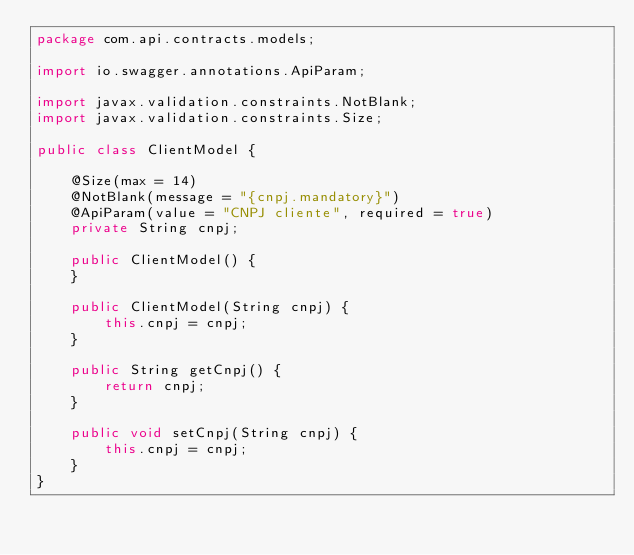Convert code to text. <code><loc_0><loc_0><loc_500><loc_500><_Java_>package com.api.contracts.models;

import io.swagger.annotations.ApiParam;

import javax.validation.constraints.NotBlank;
import javax.validation.constraints.Size;

public class ClientModel {

    @Size(max = 14)
    @NotBlank(message = "{cnpj.mandatory}")
    @ApiParam(value = "CNPJ cliente", required = true)
    private String cnpj;

    public ClientModel() {
    }

    public ClientModel(String cnpj) {
        this.cnpj = cnpj;
    }

    public String getCnpj() {
        return cnpj;
    }

    public void setCnpj(String cnpj) {
        this.cnpj = cnpj;
    }
}</code> 